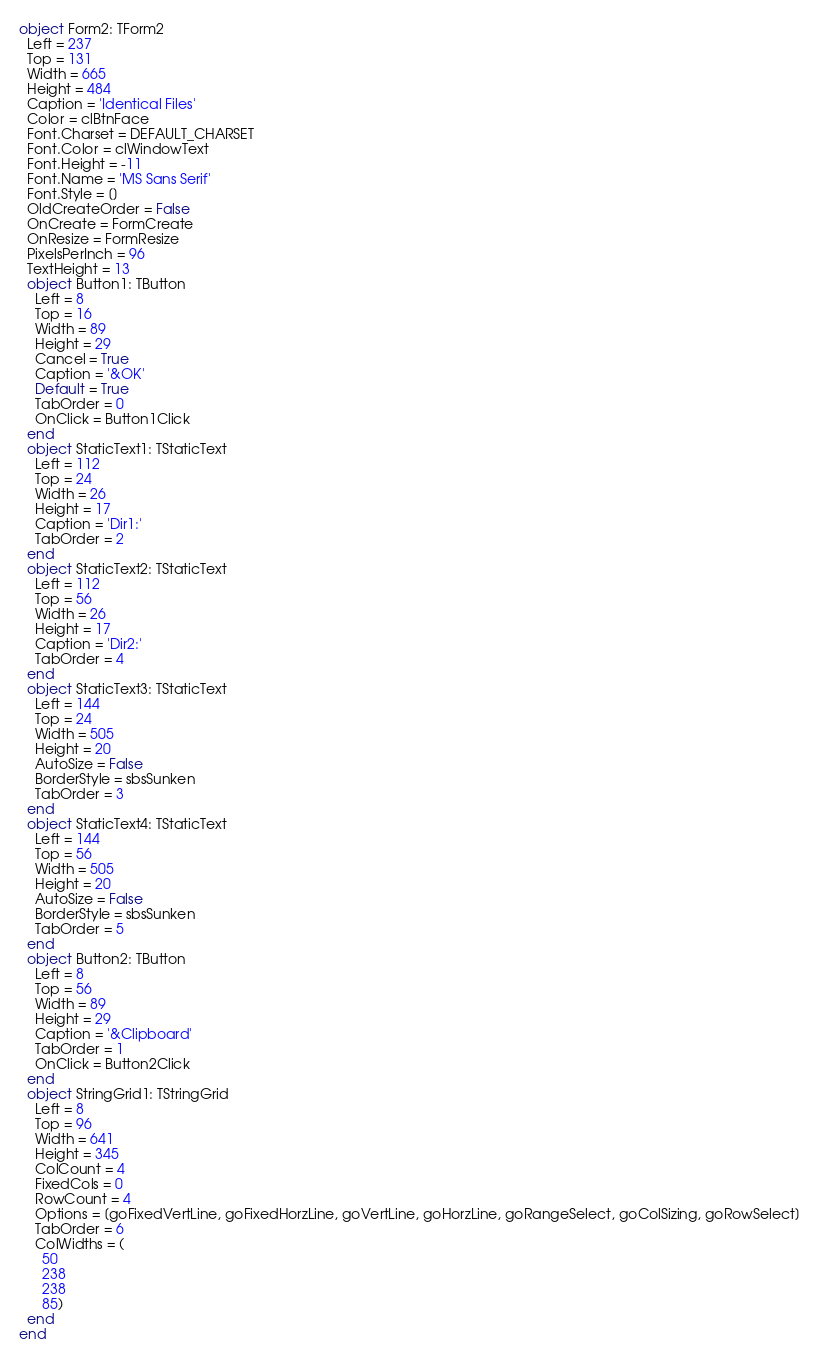<code> <loc_0><loc_0><loc_500><loc_500><_Pascal_>object Form2: TForm2
  Left = 237
  Top = 131
  Width = 665
  Height = 484
  Caption = 'Identical Files'
  Color = clBtnFace
  Font.Charset = DEFAULT_CHARSET
  Font.Color = clWindowText
  Font.Height = -11
  Font.Name = 'MS Sans Serif'
  Font.Style = []
  OldCreateOrder = False
  OnCreate = FormCreate
  OnResize = FormResize
  PixelsPerInch = 96
  TextHeight = 13
  object Button1: TButton
    Left = 8
    Top = 16
    Width = 89
    Height = 29
    Cancel = True
    Caption = '&OK'
    Default = True
    TabOrder = 0
    OnClick = Button1Click
  end
  object StaticText1: TStaticText
    Left = 112
    Top = 24
    Width = 26
    Height = 17
    Caption = 'Dir1:'
    TabOrder = 2
  end
  object StaticText2: TStaticText
    Left = 112
    Top = 56
    Width = 26
    Height = 17
    Caption = 'Dir2:'
    TabOrder = 4
  end
  object StaticText3: TStaticText
    Left = 144
    Top = 24
    Width = 505
    Height = 20
    AutoSize = False
    BorderStyle = sbsSunken
    TabOrder = 3
  end
  object StaticText4: TStaticText
    Left = 144
    Top = 56
    Width = 505
    Height = 20
    AutoSize = False
    BorderStyle = sbsSunken
    TabOrder = 5
  end
  object Button2: TButton
    Left = 8
    Top = 56
    Width = 89
    Height = 29
    Caption = '&Clipboard'
    TabOrder = 1
    OnClick = Button2Click
  end
  object StringGrid1: TStringGrid
    Left = 8
    Top = 96
    Width = 641
    Height = 345
    ColCount = 4
    FixedCols = 0
    RowCount = 4
    Options = [goFixedVertLine, goFixedHorzLine, goVertLine, goHorzLine, goRangeSelect, goColSizing, goRowSelect]
    TabOrder = 6
    ColWidths = (
      50
      238
      238
      85)
  end
end
</code> 